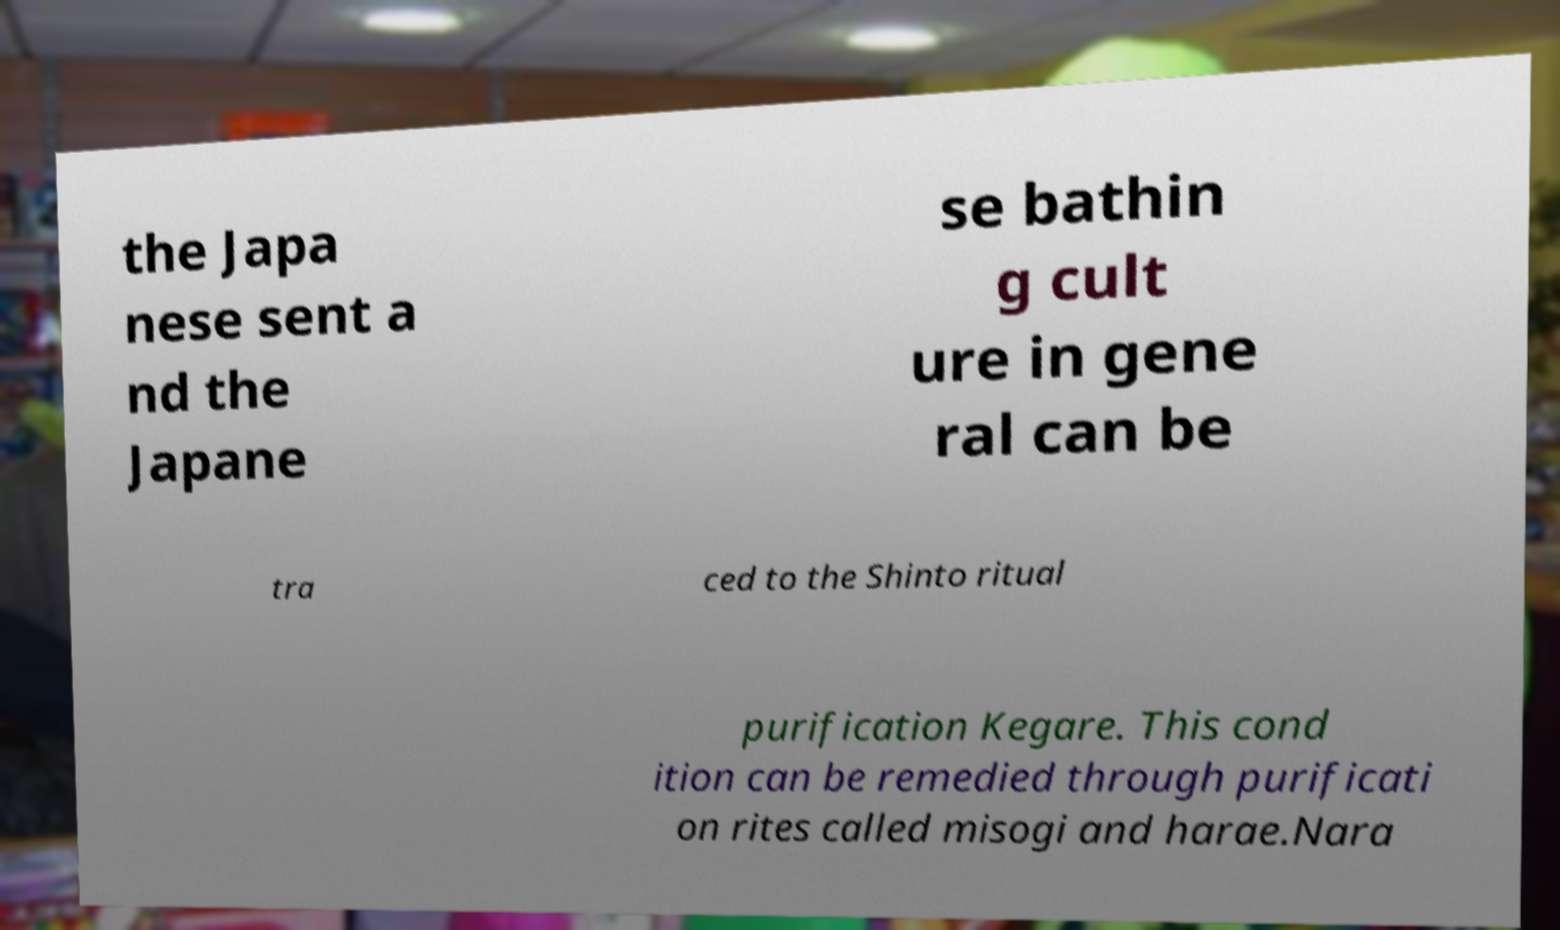Could you extract and type out the text from this image? the Japa nese sent a nd the Japane se bathin g cult ure in gene ral can be tra ced to the Shinto ritual purification Kegare. This cond ition can be remedied through purificati on rites called misogi and harae.Nara 